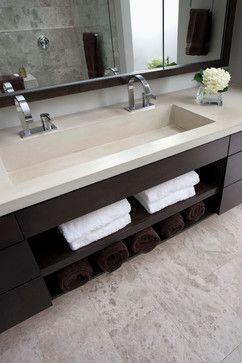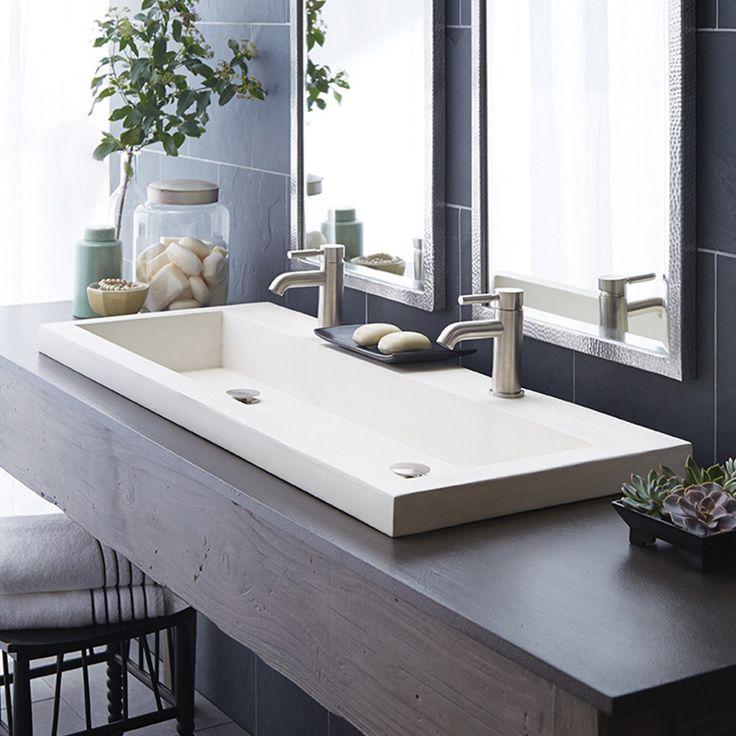The first image is the image on the left, the second image is the image on the right. Assess this claim about the two images: "Each of the vanity sinks pictured has two faucets.". Correct or not? Answer yes or no. Yes. 